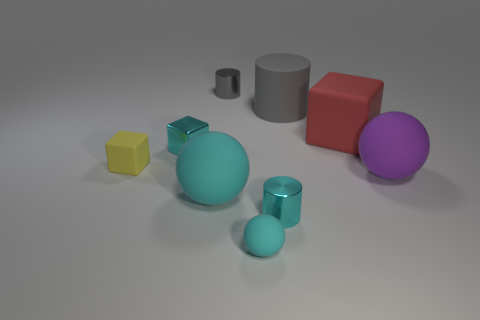Are there any cyan objects that are behind the tiny cylinder in front of the yellow object?
Keep it short and to the point. Yes. Do the shiny cylinder that is in front of the yellow matte object and the big matte cylinder have the same size?
Keep it short and to the point. No. What is the size of the purple object?
Your response must be concise. Large. Is there a metallic thing of the same color as the shiny cube?
Keep it short and to the point. Yes. How many big things are either cubes or cyan blocks?
Provide a short and direct response. 1. What is the size of the rubber object that is to the left of the big matte cylinder and behind the purple object?
Your answer should be compact. Small. There is a purple rubber sphere; what number of small shiny objects are in front of it?
Provide a succinct answer. 1. There is a large thing that is both in front of the small yellow rubber block and right of the large gray rubber thing; what shape is it?
Provide a short and direct response. Sphere. There is another cylinder that is the same color as the large rubber cylinder; what material is it?
Ensure brevity in your answer.  Metal. How many cylinders are either big rubber things or big green matte objects?
Give a very brief answer. 1. 